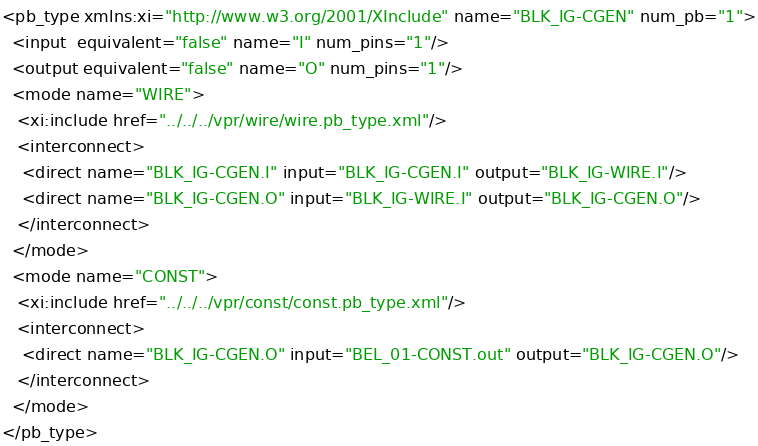Convert code to text. <code><loc_0><loc_0><loc_500><loc_500><_XML_><pb_type xmlns:xi="http://www.w3.org/2001/XInclude" name="BLK_IG-CGEN" num_pb="1">
  <input  equivalent="false" name="I" num_pins="1"/>
  <output equivalent="false" name="O" num_pins="1"/>
  <mode name="WIRE">
   <xi:include href="../../../vpr/wire/wire.pb_type.xml"/>
   <interconnect>
    <direct name="BLK_IG-CGEN.I" input="BLK_IG-CGEN.I" output="BLK_IG-WIRE.I"/>
    <direct name="BLK_IG-CGEN.O" input="BLK_IG-WIRE.I" output="BLK_IG-CGEN.O"/>
   </interconnect>
  </mode>
  <mode name="CONST">
   <xi:include href="../../../vpr/const/const.pb_type.xml"/>
   <interconnect>
    <direct name="BLK_IG-CGEN.O" input="BEL_01-CONST.out" output="BLK_IG-CGEN.O"/>
   </interconnect>
  </mode>
</pb_type>
</code> 